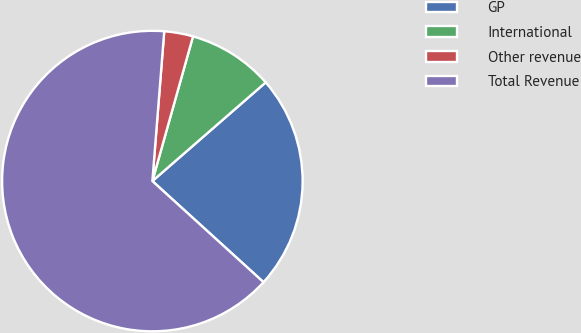<chart> <loc_0><loc_0><loc_500><loc_500><pie_chart><fcel>GP<fcel>International<fcel>Other revenue<fcel>Total Revenue<nl><fcel>23.15%<fcel>9.24%<fcel>3.1%<fcel>64.51%<nl></chart> 